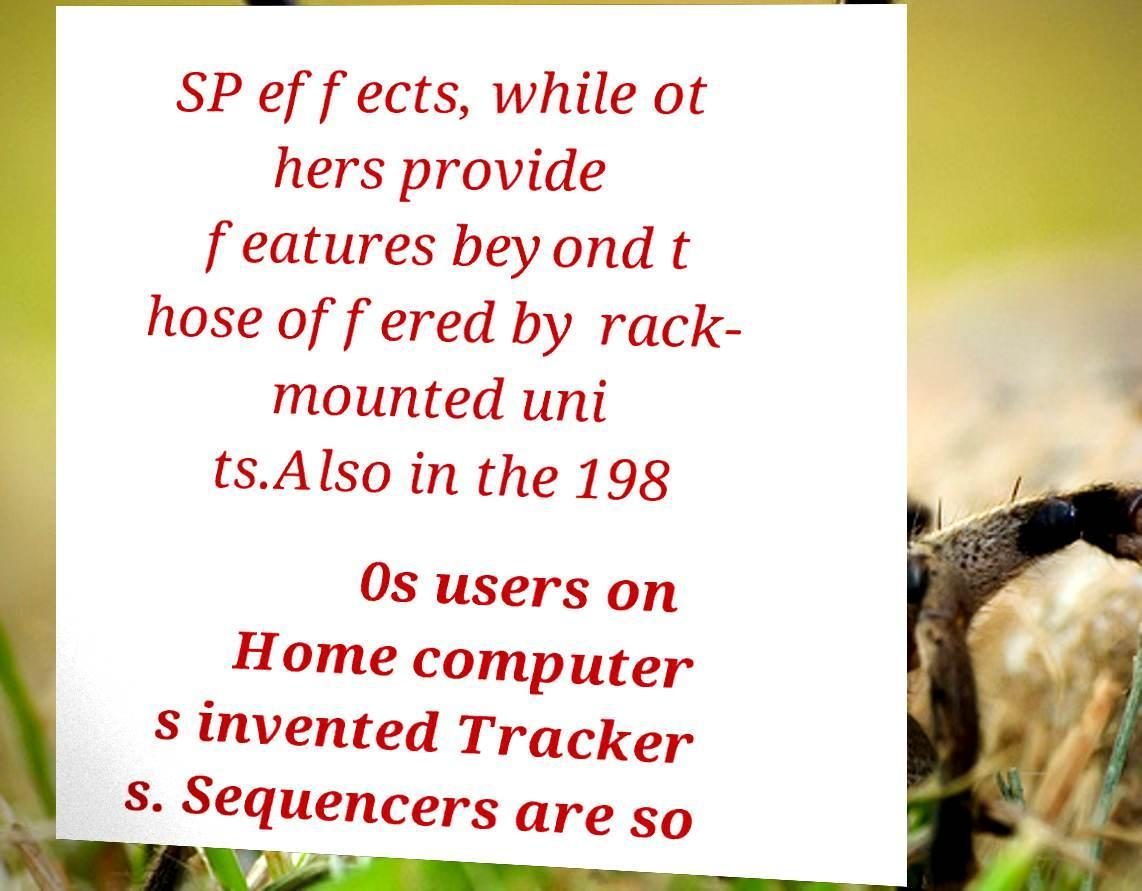Can you accurately transcribe the text from the provided image for me? SP effects, while ot hers provide features beyond t hose offered by rack- mounted uni ts.Also in the 198 0s users on Home computer s invented Tracker s. Sequencers are so 